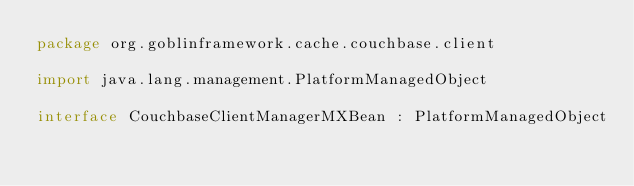<code> <loc_0><loc_0><loc_500><loc_500><_Kotlin_>package org.goblinframework.cache.couchbase.client

import java.lang.management.PlatformManagedObject

interface CouchbaseClientManagerMXBean : PlatformManagedObject</code> 